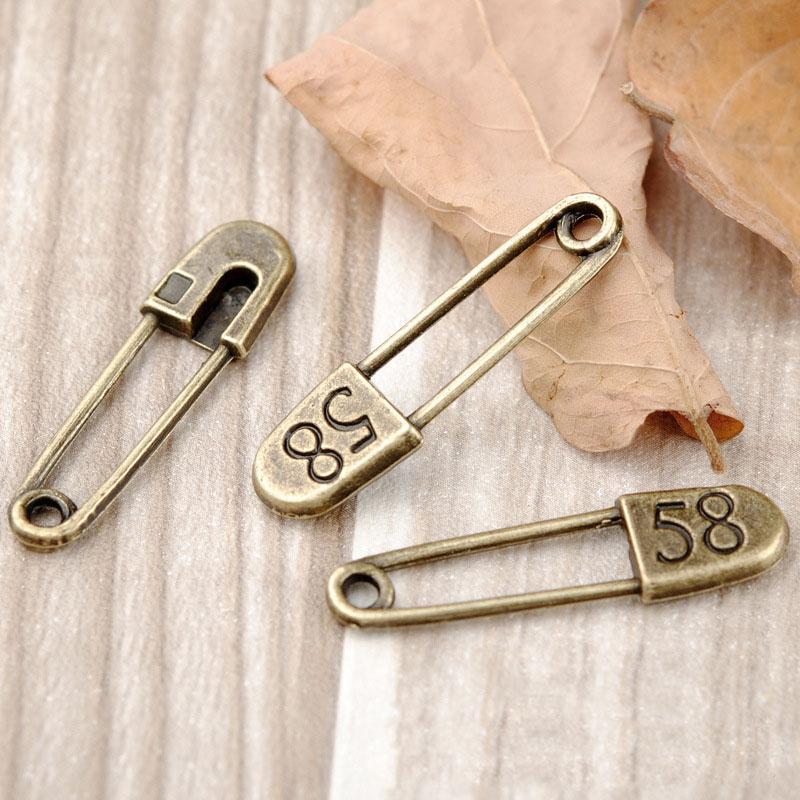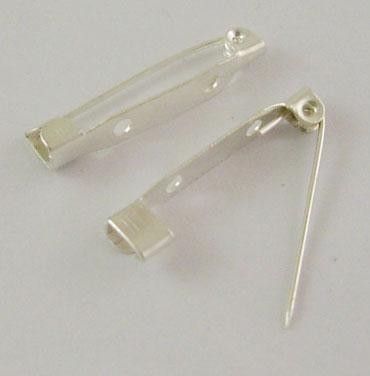The first image is the image on the left, the second image is the image on the right. Evaluate the accuracy of this statement regarding the images: "Each photo contains a single safety pin with a decorative clasp.". Is it true? Answer yes or no. No. 